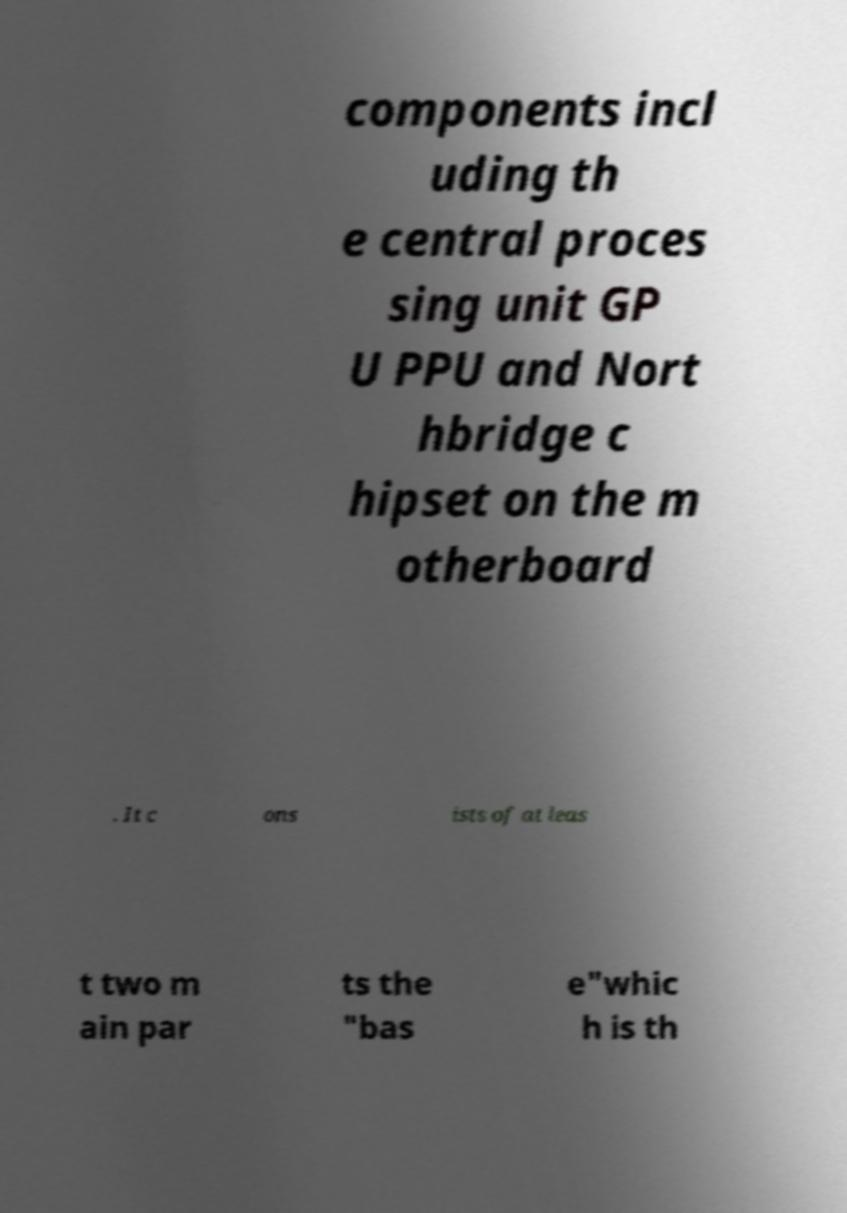Could you extract and type out the text from this image? components incl uding th e central proces sing unit GP U PPU and Nort hbridge c hipset on the m otherboard . It c ons ists of at leas t two m ain par ts the "bas e"whic h is th 